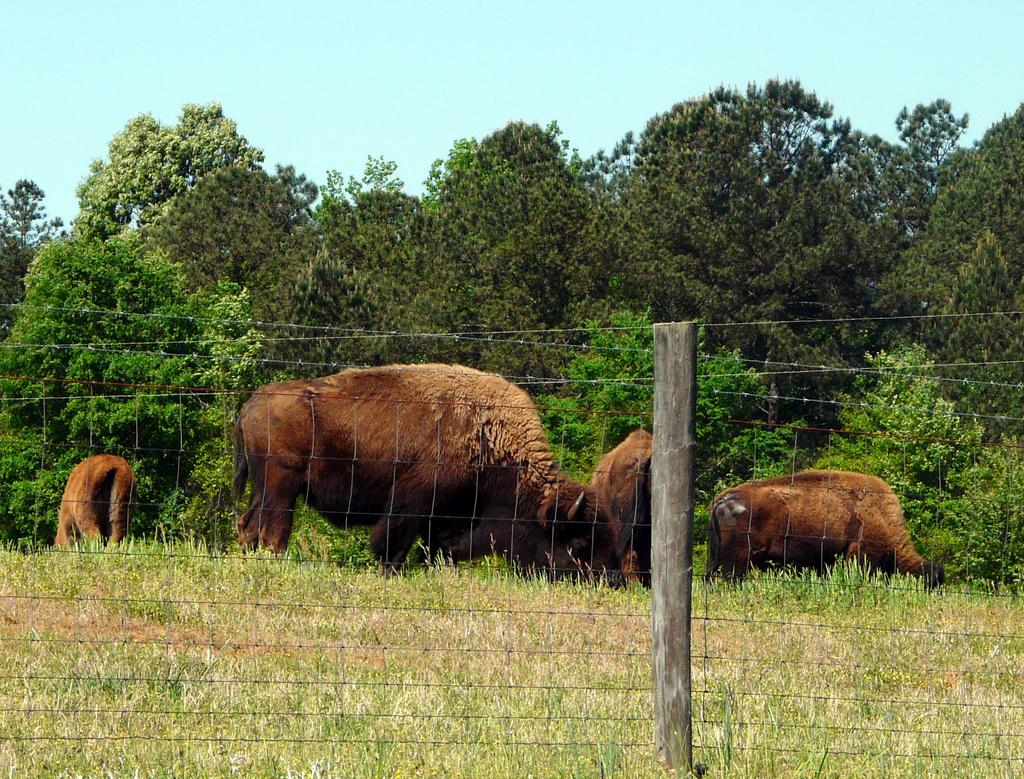What is located in the center of the image? There are animals in the center of the image. What can be seen surrounding the animals? There is a fence in the image. What type of natural environment is visible in the background? There are trees in the background of the image. What is visible at the top of the image? The sky is visible at the top of the image. What type of copper material is used to build the fence in the image? There is no mention of copper or any specific material used for the fence in the image. The fence is simply described as being present. 